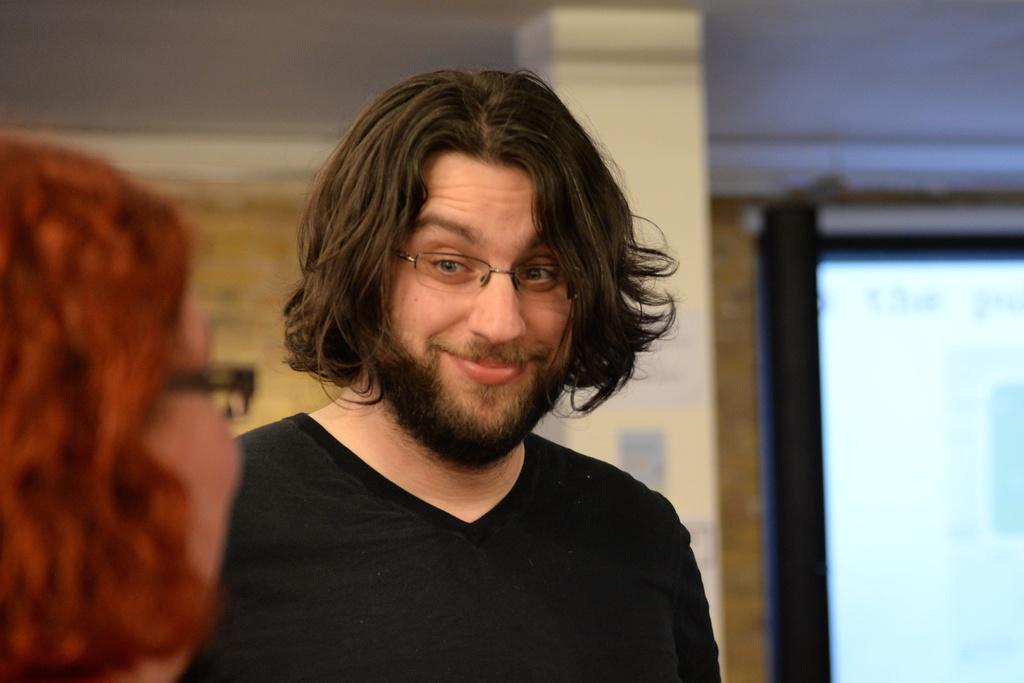Describe this image in one or two sentences. In this picture there is a man standing and smiling and there is a woman. At the back there is a pillar and there is a screen and there is text on the screen and there is a wall. 